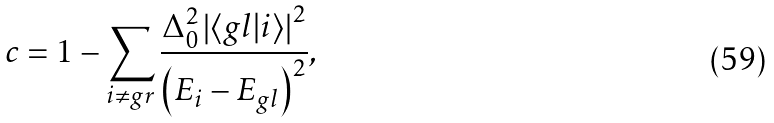Convert formula to latex. <formula><loc_0><loc_0><loc_500><loc_500>c = 1 - \sum _ { i \neq g r } \frac { \Delta _ { 0 } ^ { 2 } \left | \langle g l | i \rangle \right | ^ { 2 } } { \left ( E _ { i } - E _ { g l } \right ) ^ { 2 } } ,</formula> 